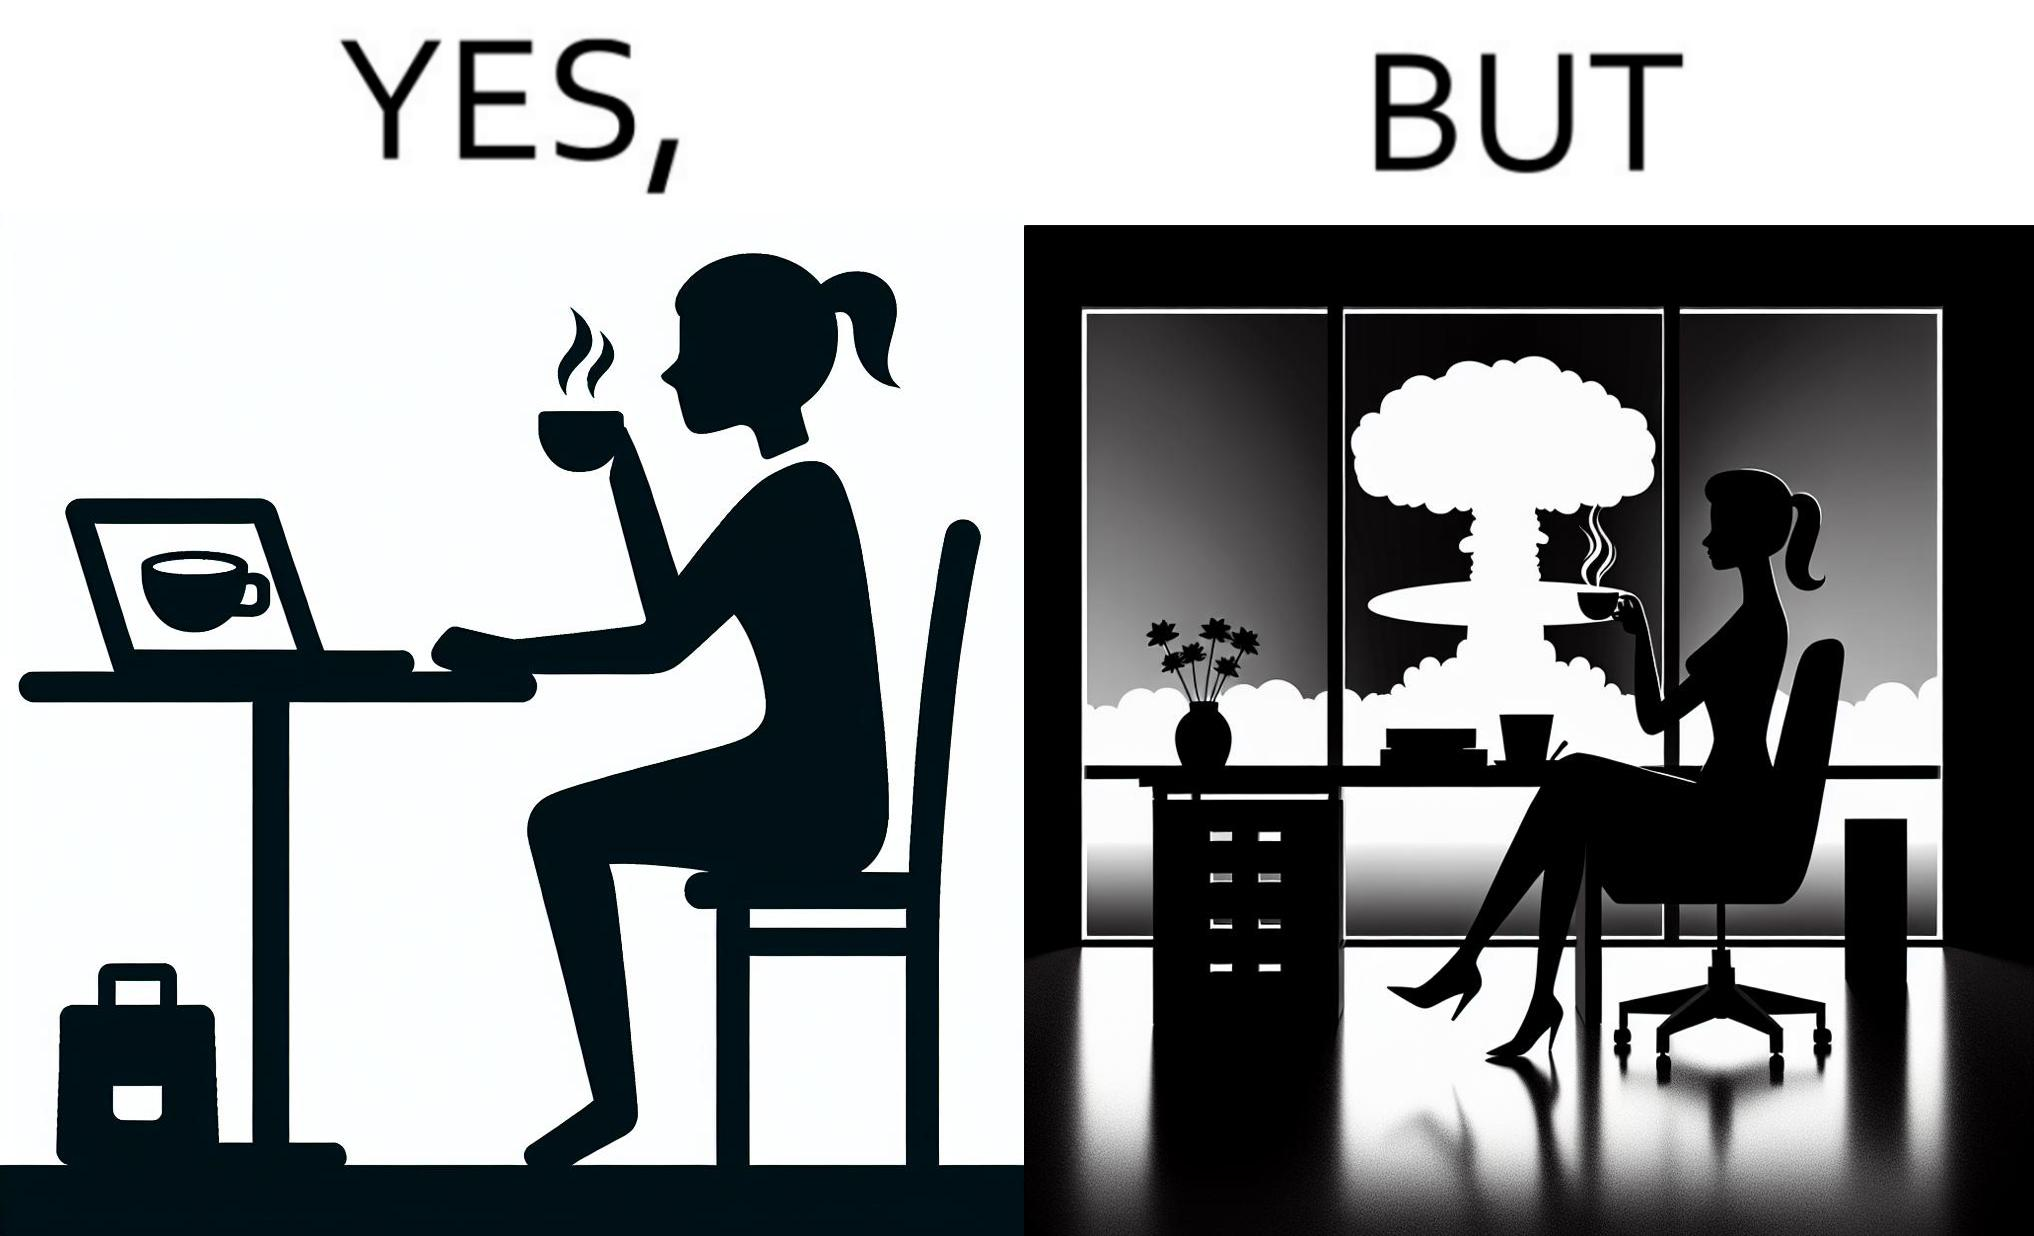Does this image contain satire or humor? Yes, this image is satirical. 